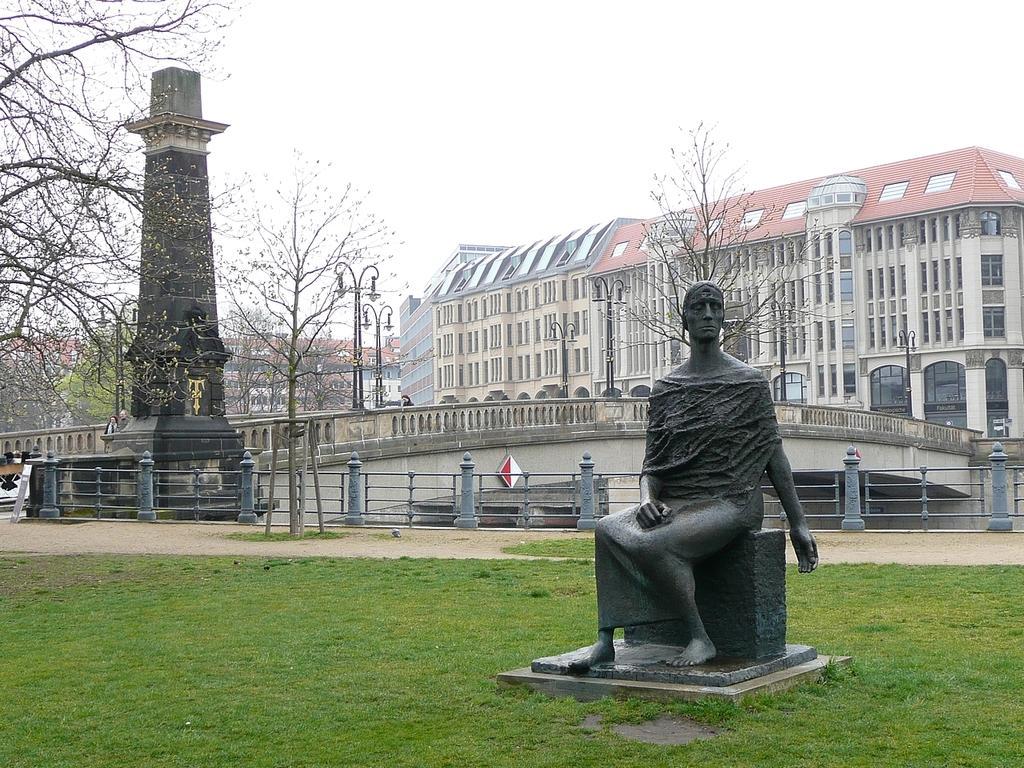In one or two sentences, can you explain what this image depicts? In this picture we can observe a statue. There is some grass on the ground. We can observe a railing and a pillar. There is a bridge here. In the background there is a building and a sky. We can observe some trees. 